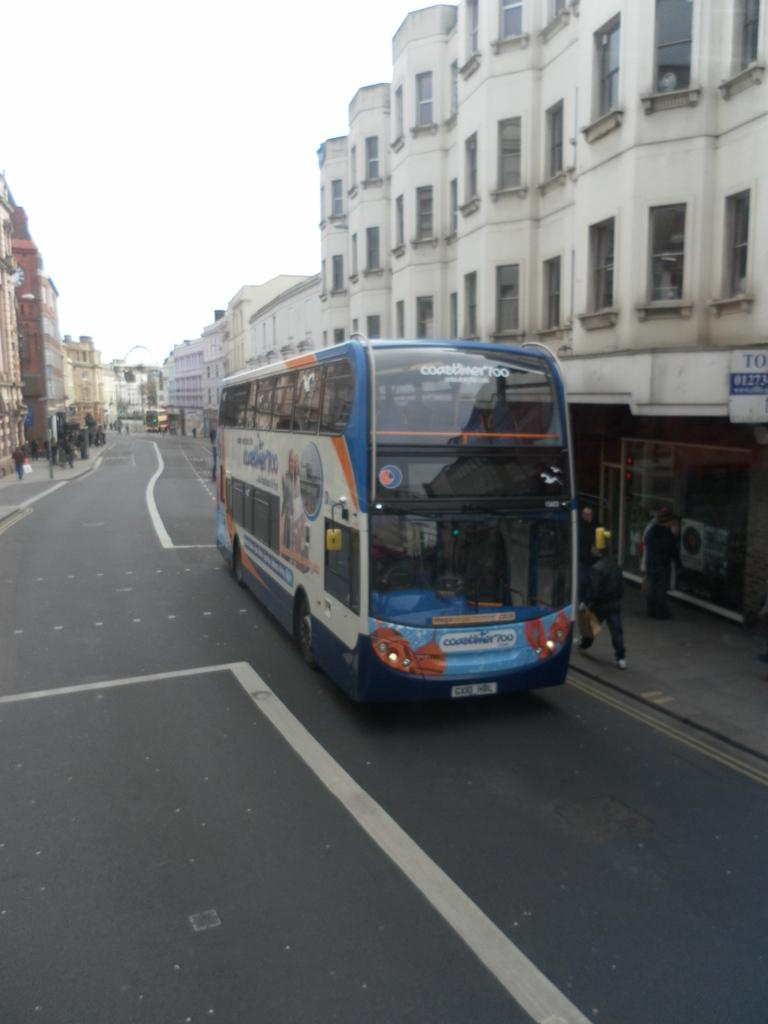What is the main subject of the image? There is a bus in the image. Where is the bus located? The bus is on the road. What can be seen in the background of the image? There are people, buildings, and the sky visible in the background of the image. What type of powder is being used by the father in the image? There is no father or powder present in the image. Can you tell me how many baskets are visible in the image? There are no baskets present in the image. 